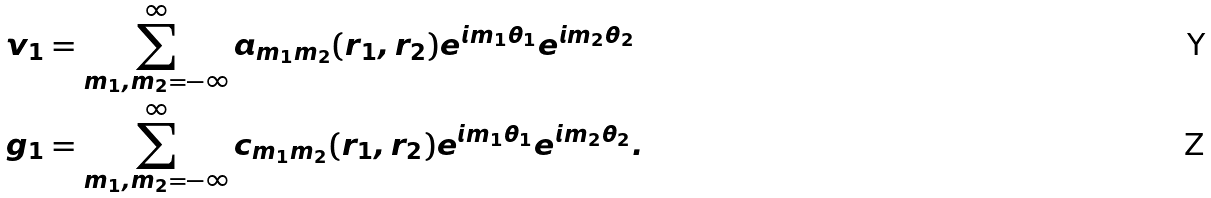Convert formula to latex. <formula><loc_0><loc_0><loc_500><loc_500>v _ { 1 } & = \sum _ { m _ { 1 } , m _ { 2 } = - \infty } ^ { \infty } a _ { m _ { 1 } m _ { 2 } } ( r _ { 1 } , r _ { 2 } ) e ^ { i m _ { 1 } \theta _ { 1 } } e ^ { i m _ { 2 } \theta _ { 2 } } \\ g _ { 1 } & = \sum _ { m _ { 1 } , m _ { 2 } = - \infty } ^ { \infty } c _ { m _ { 1 } m _ { 2 } } ( r _ { 1 } , r _ { 2 } ) e ^ { i m _ { 1 } \theta _ { 1 } } e ^ { i m _ { 2 } \theta _ { 2 } } .</formula> 